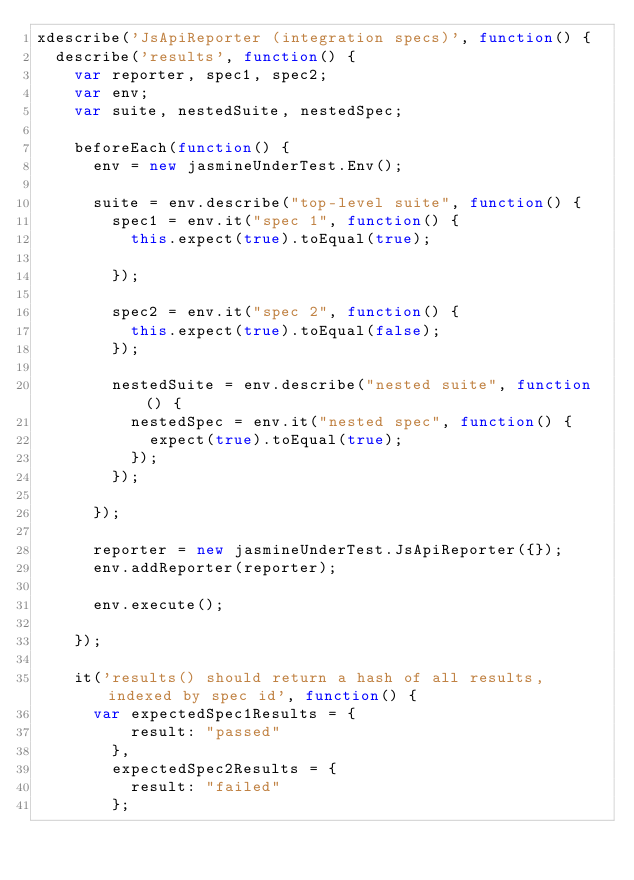Convert code to text. <code><loc_0><loc_0><loc_500><loc_500><_JavaScript_>xdescribe('JsApiReporter (integration specs)', function() {
  describe('results', function() {
    var reporter, spec1, spec2;
    var env;
    var suite, nestedSuite, nestedSpec;

    beforeEach(function() {
      env = new jasmineUnderTest.Env();

      suite = env.describe("top-level suite", function() {
        spec1 = env.it("spec 1", function() {
          this.expect(true).toEqual(true);

        });

        spec2 = env.it("spec 2", function() {
          this.expect(true).toEqual(false);
        });

        nestedSuite = env.describe("nested suite", function() {
          nestedSpec = env.it("nested spec", function() {
            expect(true).toEqual(true);
          });
        });

      });

      reporter = new jasmineUnderTest.JsApiReporter({});
      env.addReporter(reporter);

      env.execute();

    });

    it('results() should return a hash of all results, indexed by spec id', function() {
      var expectedSpec1Results = {
          result: "passed"
        },
        expectedSpec2Results = {
          result: "failed"
        };</code> 